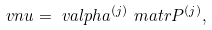<formula> <loc_0><loc_0><loc_500><loc_500>\ v n u & = \ v a l p h a ^ { ( j ) } \ m a t r { P } ^ { ( j ) } ,</formula> 